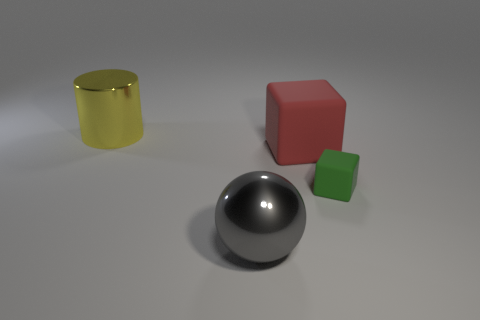Are there any other things that are the same size as the green matte cube?
Provide a succinct answer. No. There is a metal thing that is behind the red block; is its size the same as the object to the right of the red matte block?
Your response must be concise. No. Is there a yellow cylinder of the same size as the gray metallic object?
Make the answer very short. Yes. Do the rubber thing that is left of the tiny object and the green object have the same shape?
Ensure brevity in your answer.  Yes. There is a large object to the left of the sphere; what is it made of?
Provide a short and direct response. Metal. The metal thing in front of the large yellow cylinder that is to the left of the tiny green thing is what shape?
Provide a short and direct response. Sphere. There is a green rubber object; is its shape the same as the matte thing that is behind the small green matte cube?
Your response must be concise. Yes. What number of red matte objects are to the right of the shiny thing that is on the right side of the yellow thing?
Your answer should be compact. 1. What is the material of the green object that is the same shape as the large red matte thing?
Offer a terse response. Rubber. How many green objects are small cubes or big matte objects?
Give a very brief answer. 1. 